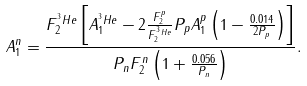Convert formula to latex. <formula><loc_0><loc_0><loc_500><loc_500>A _ { 1 } ^ { n } = \frac { F _ { 2 } ^ { ^ { 3 } H e } \left [ A _ { 1 } ^ { ^ { 3 } H e } - 2 \frac { F _ { 2 } ^ { p } } { F _ { 2 } ^ { ^ { 3 } H e } } P _ { p } A _ { 1 } ^ { p } \left ( 1 - \frac { 0 . 0 1 4 } { 2 P _ { p } } \right ) \right ] } { P _ { n } F _ { 2 } ^ { n } \left ( 1 + \frac { 0 . 0 5 6 } { P _ { n } } \right ) } .</formula> 